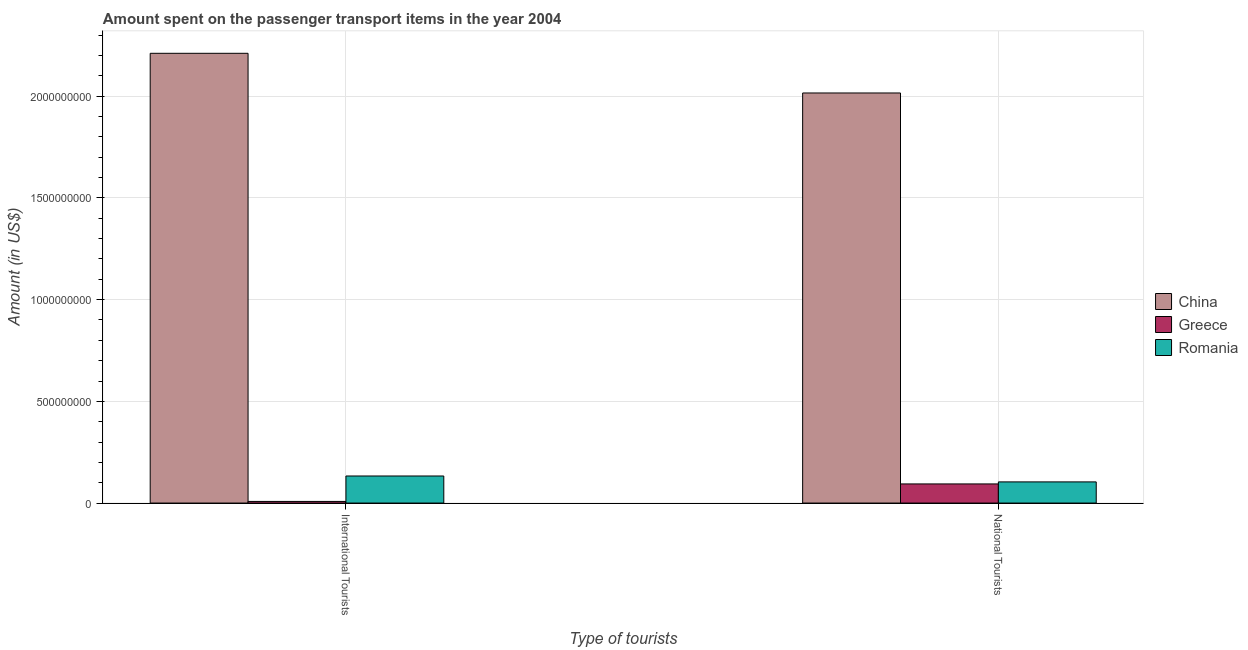Are the number of bars on each tick of the X-axis equal?
Your response must be concise. Yes. What is the label of the 2nd group of bars from the left?
Your answer should be very brief. National Tourists. What is the amount spent on transport items of international tourists in China?
Ensure brevity in your answer.  2.21e+09. Across all countries, what is the maximum amount spent on transport items of international tourists?
Make the answer very short. 2.21e+09. Across all countries, what is the minimum amount spent on transport items of international tourists?
Keep it short and to the point. 8.00e+06. In which country was the amount spent on transport items of international tourists maximum?
Your answer should be compact. China. What is the total amount spent on transport items of national tourists in the graph?
Provide a succinct answer. 2.21e+09. What is the difference between the amount spent on transport items of international tourists in Romania and that in China?
Offer a very short reply. -2.08e+09. What is the difference between the amount spent on transport items of international tourists in Greece and the amount spent on transport items of national tourists in China?
Offer a very short reply. -2.01e+09. What is the average amount spent on transport items of national tourists per country?
Your answer should be very brief. 7.38e+08. What is the difference between the amount spent on transport items of international tourists and amount spent on transport items of national tourists in Romania?
Your response must be concise. 2.90e+07. What is the ratio of the amount spent on transport items of national tourists in China to that in Romania?
Ensure brevity in your answer.  19.38. Is the amount spent on transport items of international tourists in Romania less than that in China?
Provide a succinct answer. Yes. What does the 3rd bar from the left in National Tourists represents?
Make the answer very short. Romania. What does the 2nd bar from the right in National Tourists represents?
Keep it short and to the point. Greece. Are all the bars in the graph horizontal?
Make the answer very short. No. How many countries are there in the graph?
Provide a succinct answer. 3. What is the difference between two consecutive major ticks on the Y-axis?
Ensure brevity in your answer.  5.00e+08. Are the values on the major ticks of Y-axis written in scientific E-notation?
Your answer should be compact. No. Does the graph contain any zero values?
Offer a very short reply. No. Does the graph contain grids?
Give a very brief answer. Yes. What is the title of the graph?
Keep it short and to the point. Amount spent on the passenger transport items in the year 2004. What is the label or title of the X-axis?
Offer a terse response. Type of tourists. What is the label or title of the Y-axis?
Your answer should be very brief. Amount (in US$). What is the Amount (in US$) in China in International Tourists?
Provide a short and direct response. 2.21e+09. What is the Amount (in US$) of Romania in International Tourists?
Your answer should be compact. 1.33e+08. What is the Amount (in US$) in China in National Tourists?
Offer a terse response. 2.02e+09. What is the Amount (in US$) of Greece in National Tourists?
Your answer should be compact. 9.40e+07. What is the Amount (in US$) in Romania in National Tourists?
Your response must be concise. 1.04e+08. Across all Type of tourists, what is the maximum Amount (in US$) in China?
Your response must be concise. 2.21e+09. Across all Type of tourists, what is the maximum Amount (in US$) in Greece?
Your answer should be very brief. 9.40e+07. Across all Type of tourists, what is the maximum Amount (in US$) of Romania?
Your response must be concise. 1.33e+08. Across all Type of tourists, what is the minimum Amount (in US$) of China?
Your answer should be very brief. 2.02e+09. Across all Type of tourists, what is the minimum Amount (in US$) in Romania?
Offer a very short reply. 1.04e+08. What is the total Amount (in US$) in China in the graph?
Keep it short and to the point. 4.23e+09. What is the total Amount (in US$) of Greece in the graph?
Ensure brevity in your answer.  1.02e+08. What is the total Amount (in US$) in Romania in the graph?
Provide a succinct answer. 2.37e+08. What is the difference between the Amount (in US$) of China in International Tourists and that in National Tourists?
Offer a terse response. 1.95e+08. What is the difference between the Amount (in US$) of Greece in International Tourists and that in National Tourists?
Offer a very short reply. -8.60e+07. What is the difference between the Amount (in US$) of Romania in International Tourists and that in National Tourists?
Offer a very short reply. 2.90e+07. What is the difference between the Amount (in US$) of China in International Tourists and the Amount (in US$) of Greece in National Tourists?
Keep it short and to the point. 2.12e+09. What is the difference between the Amount (in US$) in China in International Tourists and the Amount (in US$) in Romania in National Tourists?
Your response must be concise. 2.11e+09. What is the difference between the Amount (in US$) in Greece in International Tourists and the Amount (in US$) in Romania in National Tourists?
Give a very brief answer. -9.60e+07. What is the average Amount (in US$) in China per Type of tourists?
Provide a succinct answer. 2.11e+09. What is the average Amount (in US$) of Greece per Type of tourists?
Provide a short and direct response. 5.10e+07. What is the average Amount (in US$) of Romania per Type of tourists?
Provide a short and direct response. 1.18e+08. What is the difference between the Amount (in US$) of China and Amount (in US$) of Greece in International Tourists?
Your answer should be very brief. 2.20e+09. What is the difference between the Amount (in US$) in China and Amount (in US$) in Romania in International Tourists?
Your answer should be compact. 2.08e+09. What is the difference between the Amount (in US$) of Greece and Amount (in US$) of Romania in International Tourists?
Make the answer very short. -1.25e+08. What is the difference between the Amount (in US$) in China and Amount (in US$) in Greece in National Tourists?
Offer a terse response. 1.92e+09. What is the difference between the Amount (in US$) in China and Amount (in US$) in Romania in National Tourists?
Provide a short and direct response. 1.91e+09. What is the difference between the Amount (in US$) in Greece and Amount (in US$) in Romania in National Tourists?
Give a very brief answer. -1.00e+07. What is the ratio of the Amount (in US$) of China in International Tourists to that in National Tourists?
Your answer should be very brief. 1.1. What is the ratio of the Amount (in US$) of Greece in International Tourists to that in National Tourists?
Provide a succinct answer. 0.09. What is the ratio of the Amount (in US$) in Romania in International Tourists to that in National Tourists?
Ensure brevity in your answer.  1.28. What is the difference between the highest and the second highest Amount (in US$) of China?
Keep it short and to the point. 1.95e+08. What is the difference between the highest and the second highest Amount (in US$) in Greece?
Your answer should be very brief. 8.60e+07. What is the difference between the highest and the second highest Amount (in US$) in Romania?
Offer a terse response. 2.90e+07. What is the difference between the highest and the lowest Amount (in US$) of China?
Offer a very short reply. 1.95e+08. What is the difference between the highest and the lowest Amount (in US$) in Greece?
Give a very brief answer. 8.60e+07. What is the difference between the highest and the lowest Amount (in US$) of Romania?
Offer a very short reply. 2.90e+07. 